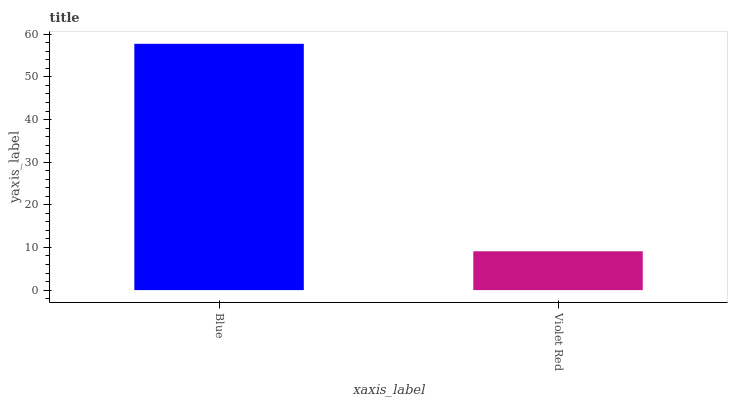Is Violet Red the minimum?
Answer yes or no. Yes. Is Blue the maximum?
Answer yes or no. Yes. Is Violet Red the maximum?
Answer yes or no. No. Is Blue greater than Violet Red?
Answer yes or no. Yes. Is Violet Red less than Blue?
Answer yes or no. Yes. Is Violet Red greater than Blue?
Answer yes or no. No. Is Blue less than Violet Red?
Answer yes or no. No. Is Blue the high median?
Answer yes or no. Yes. Is Violet Red the low median?
Answer yes or no. Yes. Is Violet Red the high median?
Answer yes or no. No. Is Blue the low median?
Answer yes or no. No. 